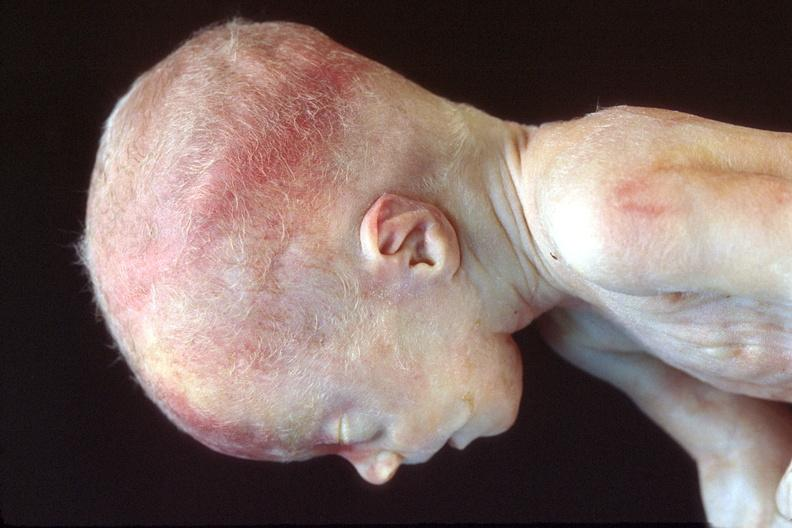does this image show hyaline membrane disease?
Answer the question using a single word or phrase. Yes 